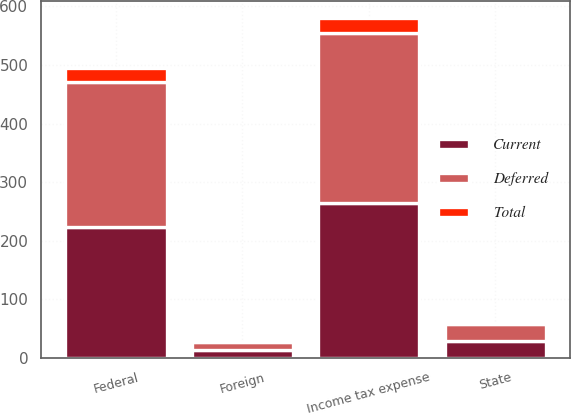Convert chart to OTSL. <chart><loc_0><loc_0><loc_500><loc_500><stacked_bar_chart><ecel><fcel>Federal<fcel>State<fcel>Foreign<fcel>Income tax expense<nl><fcel>Current<fcel>223.9<fcel>28.2<fcel>12.6<fcel>264.7<nl><fcel>Total<fcel>23.2<fcel>1.2<fcel>1.2<fcel>25.6<nl><fcel>Deferred<fcel>247.1<fcel>29.4<fcel>13.8<fcel>290.3<nl></chart> 